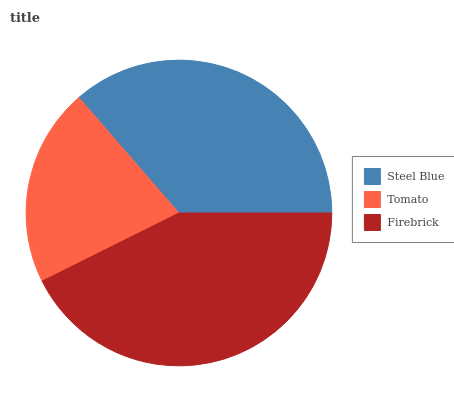Is Tomato the minimum?
Answer yes or no. Yes. Is Firebrick the maximum?
Answer yes or no. Yes. Is Firebrick the minimum?
Answer yes or no. No. Is Tomato the maximum?
Answer yes or no. No. Is Firebrick greater than Tomato?
Answer yes or no. Yes. Is Tomato less than Firebrick?
Answer yes or no. Yes. Is Tomato greater than Firebrick?
Answer yes or no. No. Is Firebrick less than Tomato?
Answer yes or no. No. Is Steel Blue the high median?
Answer yes or no. Yes. Is Steel Blue the low median?
Answer yes or no. Yes. Is Firebrick the high median?
Answer yes or no. No. Is Firebrick the low median?
Answer yes or no. No. 